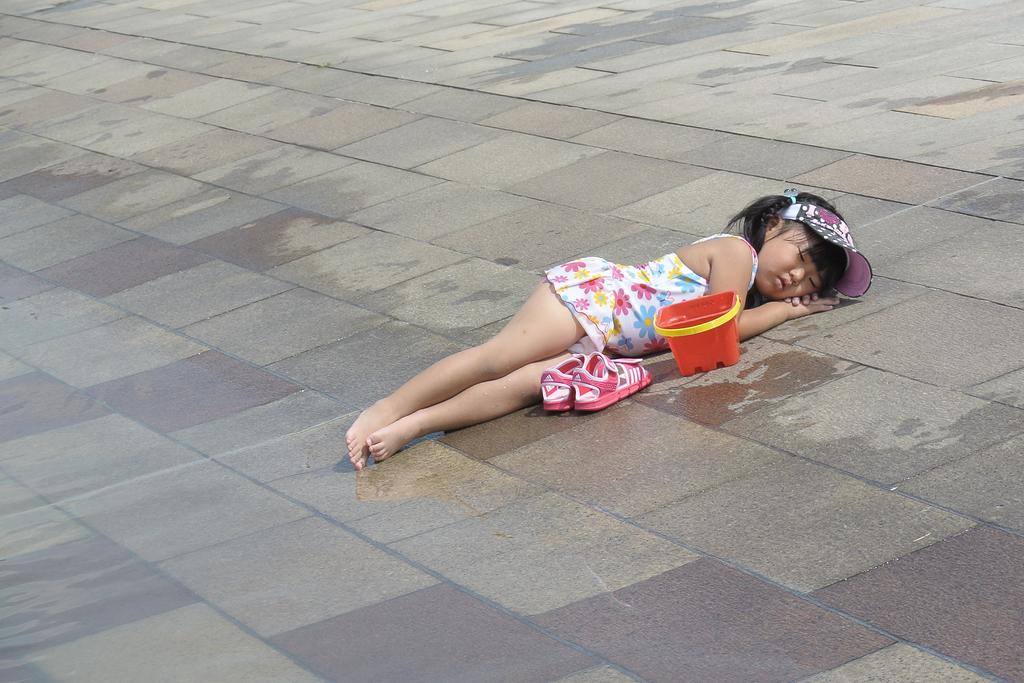What is the main subject of the image? The main subject of the image is a kid. What is the kid wearing in the image? The kid is wearing a multi-color dress in the image. What is the kid doing in the image? The kid is sleeping on the ground in the image. What objects are beside the kid in the image? There is a pair of shoes and a box beside the kid in the image. What thought is the kid having while sleeping in the image? There is no way to determine the kid's thoughts from the image, as thoughts are not visible. Can you see a building in the background of the image? No, there is no building visible in the image; it only shows the kid sleeping on the ground, a pair of shoes, and a box. 